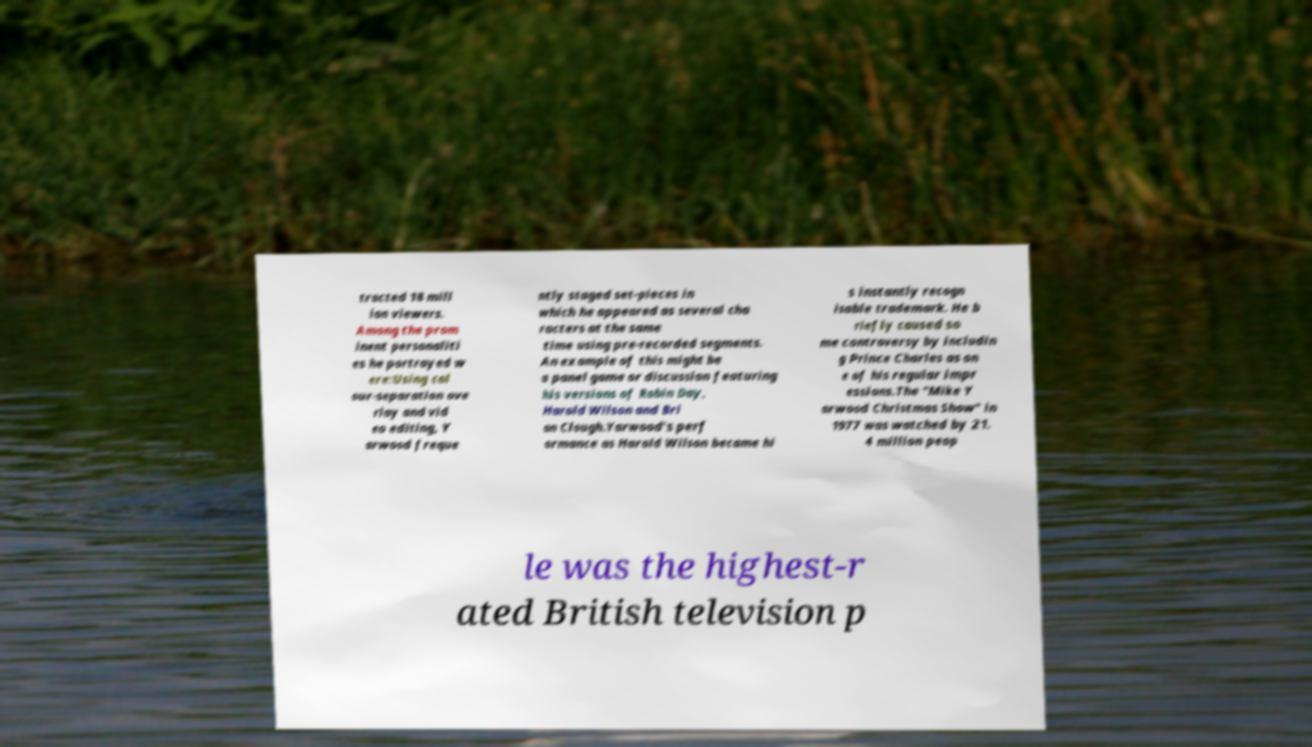I need the written content from this picture converted into text. Can you do that? tracted 18 mill ion viewers. Among the prom inent personaliti es he portrayed w ere:Using col our-separation ove rlay and vid eo editing, Y arwood freque ntly staged set-pieces in which he appeared as several cha racters at the same time using pre-recorded segments. An example of this might be a panel game or discussion featuring his versions of Robin Day, Harold Wilson and Bri an Clough.Yarwood's perf ormance as Harold Wilson became hi s instantly recogn isable trademark. He b riefly caused so me controversy by includin g Prince Charles as on e of his regular impr essions.The "Mike Y arwood Christmas Show" in 1977 was watched by 21. 4 million peop le was the highest-r ated British television p 